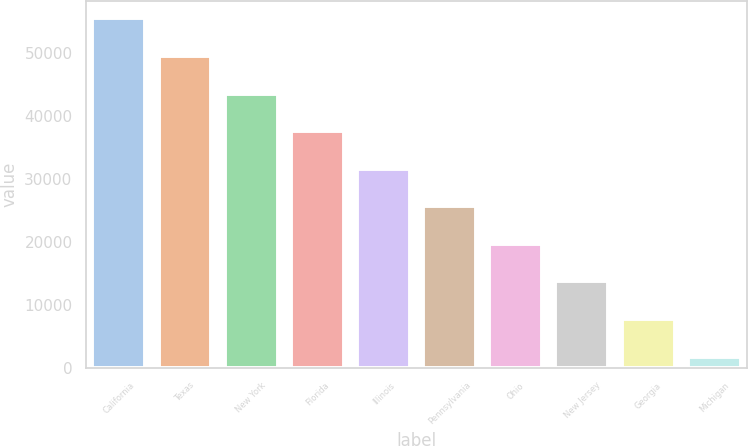Convert chart. <chart><loc_0><loc_0><loc_500><loc_500><bar_chart><fcel>California<fcel>Texas<fcel>New York<fcel>Florida<fcel>Illinois<fcel>Pennsylvania<fcel>Ohio<fcel>New Jersey<fcel>Georgia<fcel>Michigan<nl><fcel>55544.2<fcel>49566.4<fcel>43588.6<fcel>37610.8<fcel>31633<fcel>25655.2<fcel>19677.4<fcel>13699.6<fcel>7721.8<fcel>1744<nl></chart> 